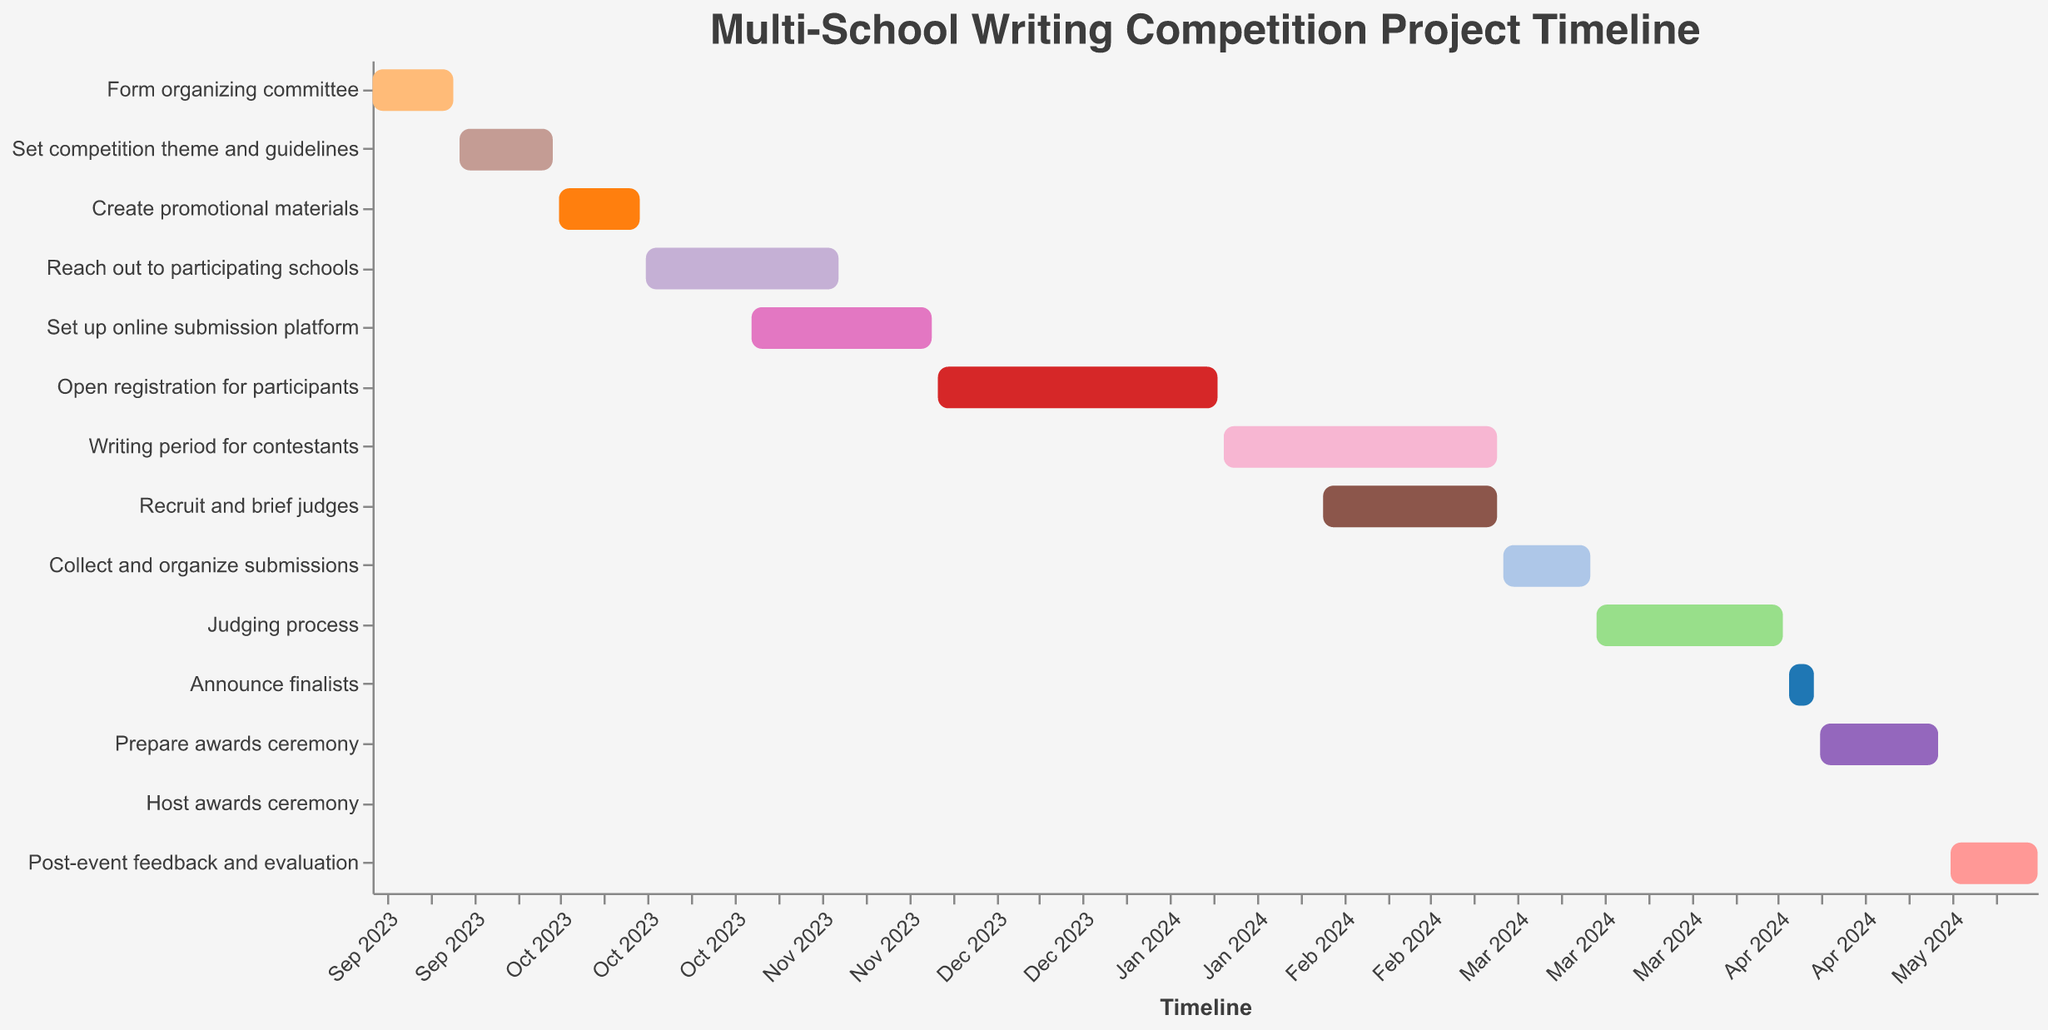What is the title of the project depicted in the Gantt chart? The title of the project is typically displayed at the top of the Gantt chart. In this case, it is "Multi-School Writing Competition Project Timeline".
Answer: Multi-School Writing Competition Project Timeline What is the duration of the ‘Writing period for contestants’? To find the duration, look at the horizontal bar corresponding to the 'Writing period for contestants' and read the tooltip or the line item in the data. The duration is given as 45 days.
Answer: 45 days Which task happens the latest in the project timeline? To find the task happening latest, look for the task bar that ends latest on the timeline axis. The last task is 'Post-event feedback and evaluation' ending on 2024-05-26.
Answer: Post-event feedback and evaluation Which two tasks overlap during February 2024? Identify tasks that are happening simultaneously by finding their date ranges. 'Writing period for contestants' and 'Recruit and brief judges' both cover the entire month of February.
Answer: Writing period for contestants and Recruit and brief judges How many days are there between the end of ‘Open registration for participants’ and the start of ‘Writing period for contestants’? Look at the end date of 'Open registration for participants' (2024-01-15) and the start date of 'Writing period for contestants' (2024-01-16). The number of days between these two dates is 1 day.
Answer: 1 day Which task has the shortest duration? Identify the task with the shortest bar on the Gantt chart, focusing on the tooltip for durations. The 'Host awards ceremony' has a duration of just 1 day.
Answer: Host awards ceremony Order the tasks by their end dates from earliest to latest. Sort the tasks based on their end dates by visually scanning the Gantt chart from left to right and noting the order. The sequence is: 
1. Form organizing committee
2. Set competition theme and guidelines
3. Create promotional materials
4. Reach out to participating schools
5. Set up online submission platform
6. Open registration for participants
7. Recruit and brief judges
8. Writing period for contestants
9. Collect and organize submissions
10. Judging process
11. Announce finalists
12. Prepare awards ceremony
13. Host awards ceremony
14. Post-event feedback and evaluation
Answer: Form organizing committee, Set competition theme and guidelines, Create promotional materials, Reach out to participating schools, Set up online submission platform, Open registration for participants, Recruit and brief judges, Writing period for contestants, Collect and organize submissions, Judging process, Announce finalists, Prepare awards ceremony, Host awards ceremony, Post-event feedback and evaluation When does the 'Judging process' start and end? Find the 'Judging process' bar and read the start and end dates from the tooltip or axis. It starts on 2024-03-16 and ends on 2024-04-15.
Answer: Starts on 2024-03-16 and ends on 2024-04-15 